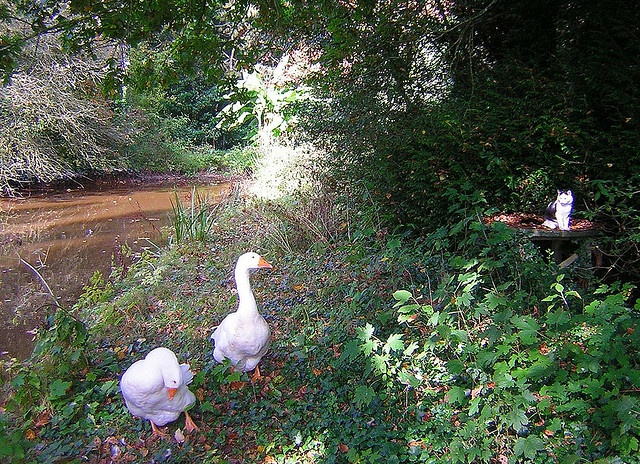Describe the objects in this image and their specific colors. I can see bird in gray, lavender, and darkgray tones, bird in gray, lavender, and darkgray tones, and cat in gray, white, black, navy, and violet tones in this image. 